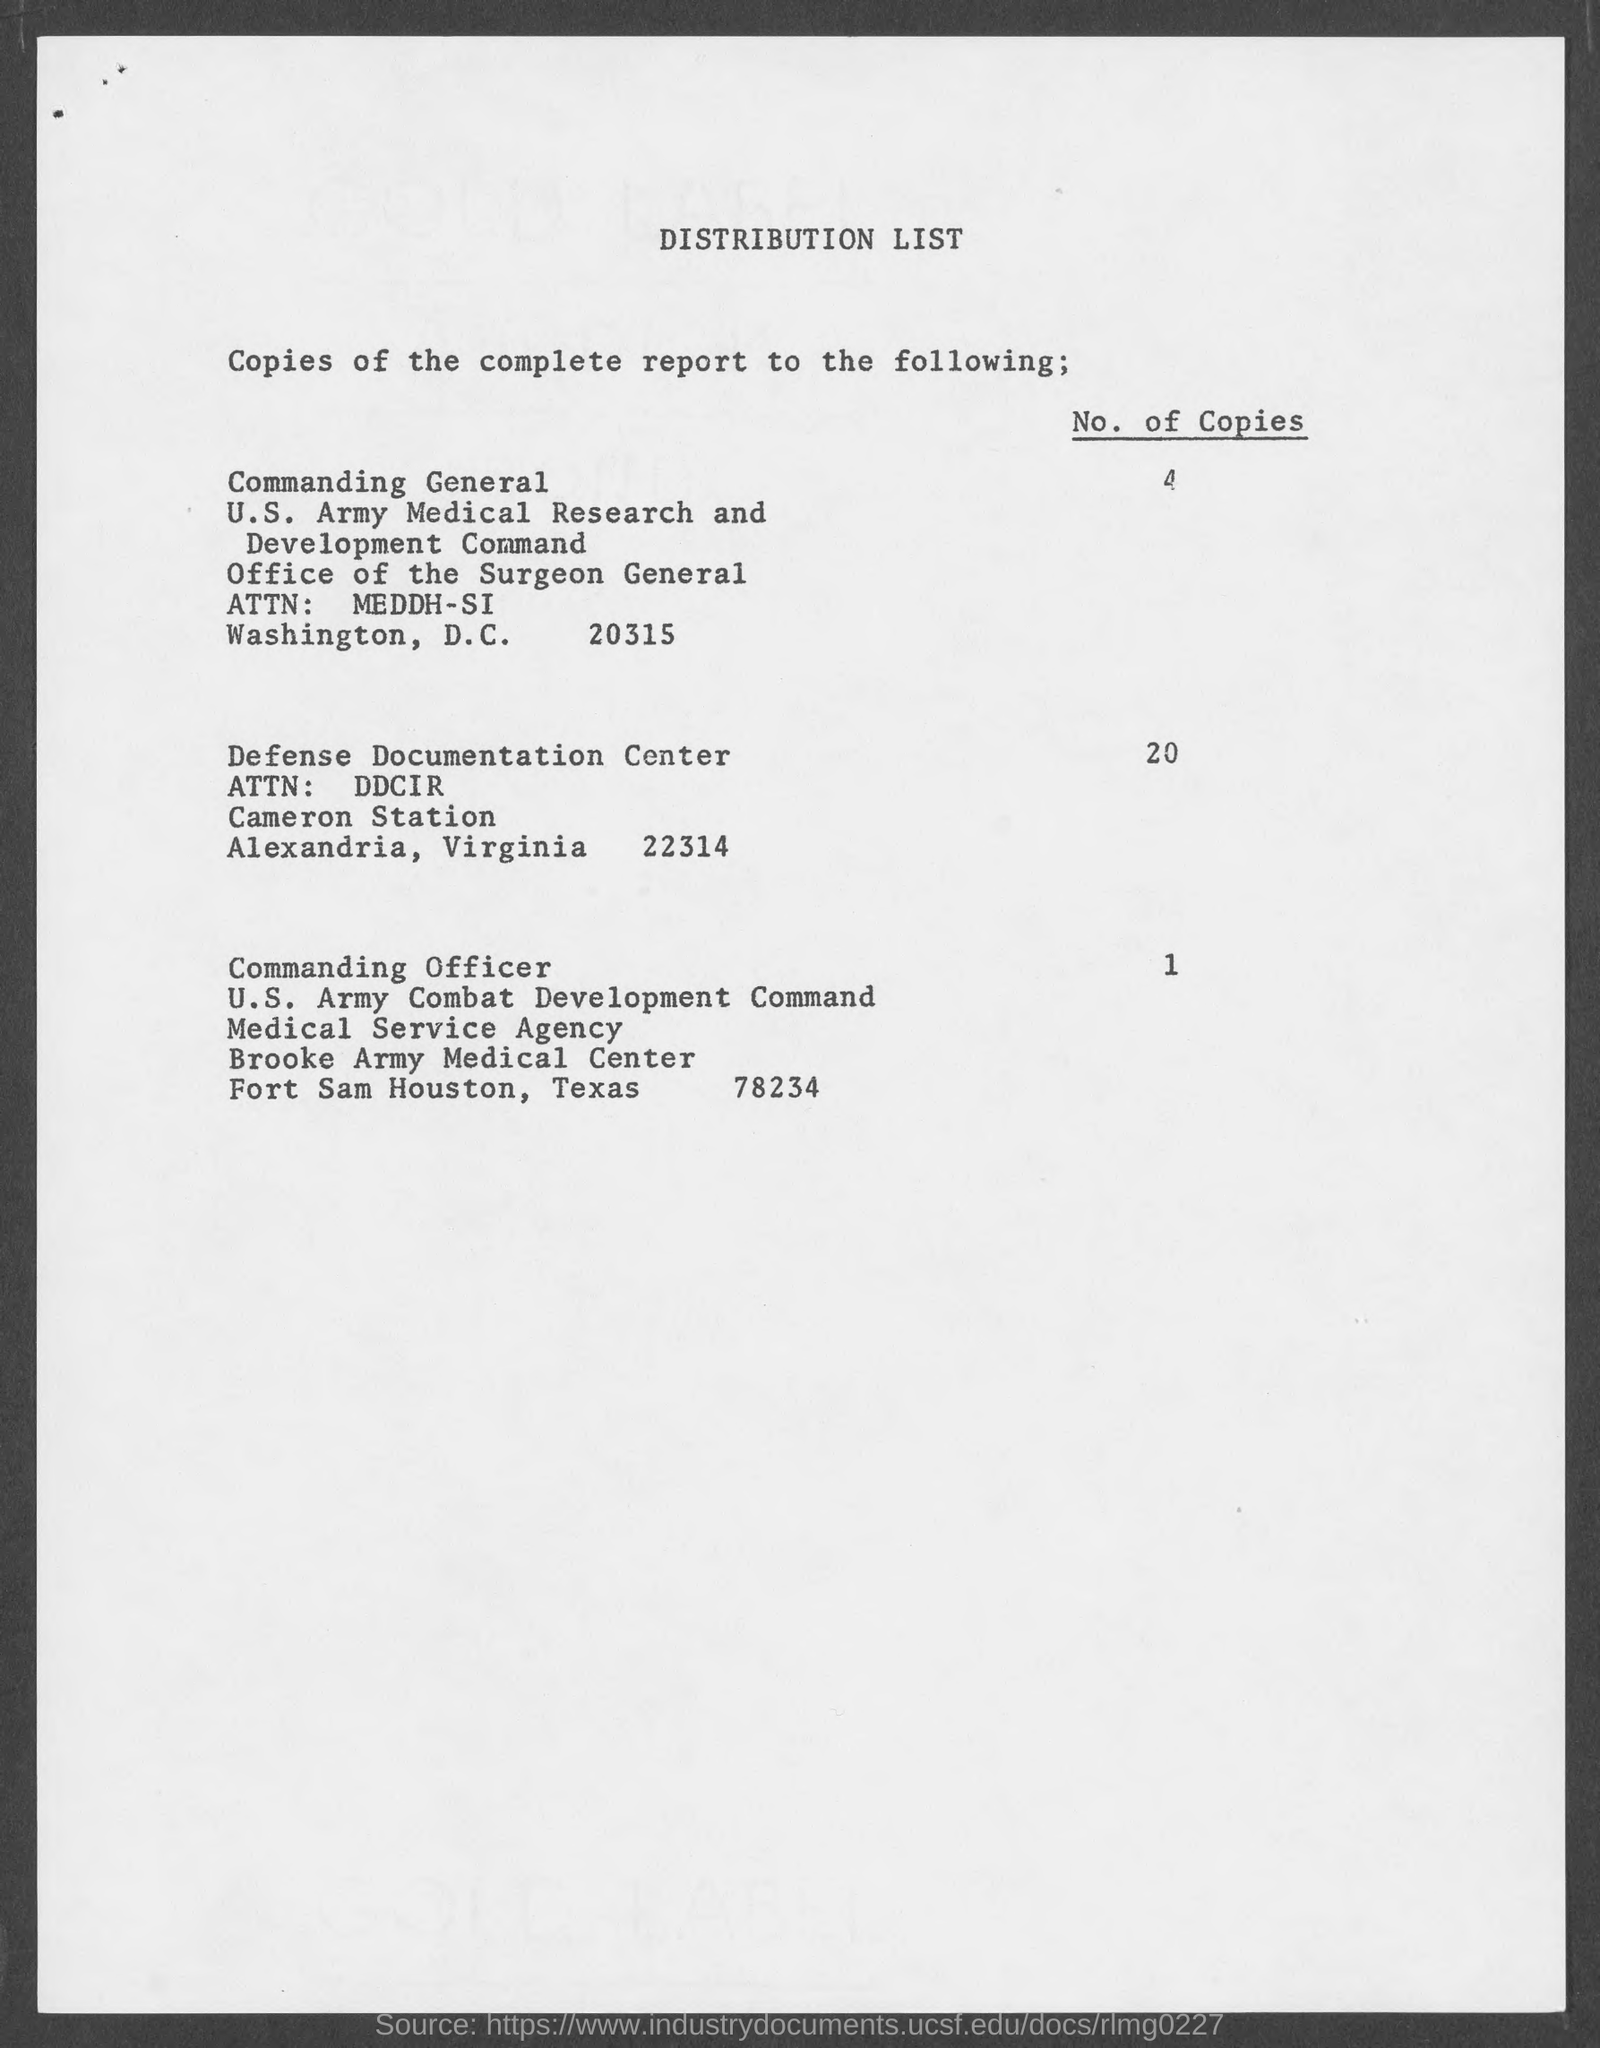Indicate a few pertinent items in this graphic. This page contains a distribution list. I am not aware of the specific number of copies that are distributed to the Commanding Officer, but I can tell you that it is generally distributed 1 copy. Four copies of the document are distributed to the Commanding General. The Defense Documentation Center is located in Alexandria County. The number of copies distributed to the Defense Documentation Center is 20. 